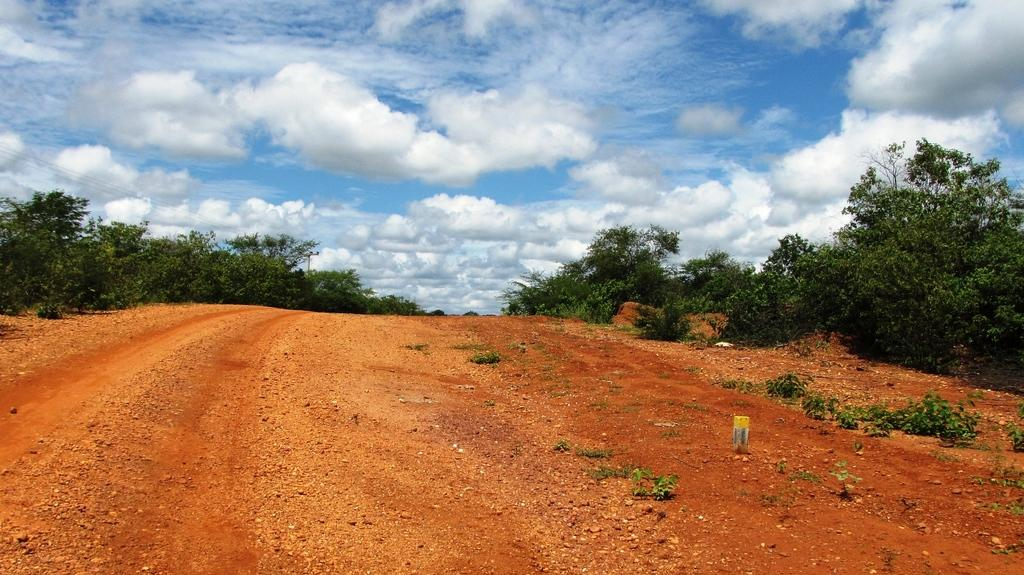What type of road is visible in the picture? There is a mud road in the picture. What can be seen on either side of the road? There are trees on either side of the road. How would you describe the sky in the picture? The sky is cloudy in the picture. What advice does the truck driver offer to the pedestrian in the image? There is no truck or pedestrian present in the image, so it is not possible to answer that question. 